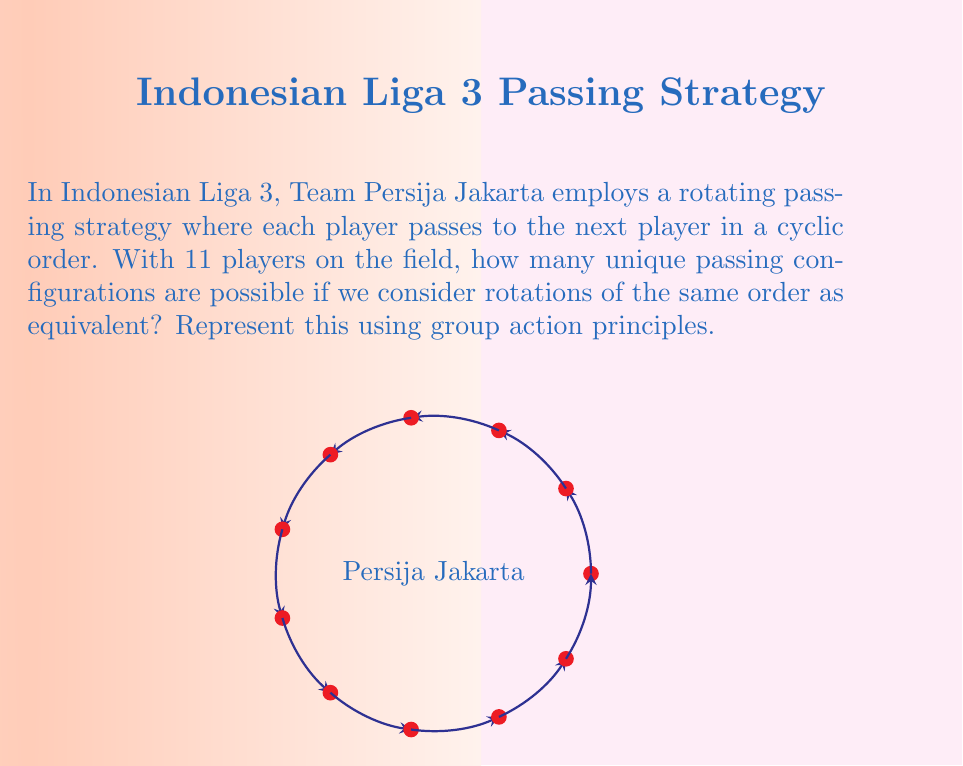Solve this math problem. Let's approach this step-by-step using group action principles:

1) First, we need to identify the group and the set it acts on:
   - The group $G$ is the cyclic group $C_{11}$ of rotations.
   - The set $X$ is the set of all possible passing orders (11! in total).

2) The group action is defined by rotating the passing order.

3) We're looking for the number of orbits under this group action. The Burnside's lemma (also known as the Cauchy-Frobenius lemma) is perfect for this:

   $$|X/G| = \frac{1}{|G|} \sum_{g \in G} |X^g|$$

   Where $|X/G|$ is the number of orbits, and $|X^g|$ is the number of elements fixed by $g$.

4) In our case:
   - $|G| = 11$ (the number of rotations)
   - For the identity element, all 11! arrangements are fixed.
   - For any non-identity rotation, only arrangements that are symmetric under that rotation are fixed. The only such arrangement is the one where all players pass in the same direction (clockwise or counterclockwise).

5) Therefore:
   $$|X/G| = \frac{1}{11} (11! + 10 \cdot 1)$$

6) Simplifying:
   $$|X/G| = \frac{11! + 10}{11} = \frac{39,916,800 + 10}{11} = 3,628,800$$

This means there are 3,628,800 unique passing configurations when considering rotations as equivalent.
Answer: 3,628,800 unique configurations 